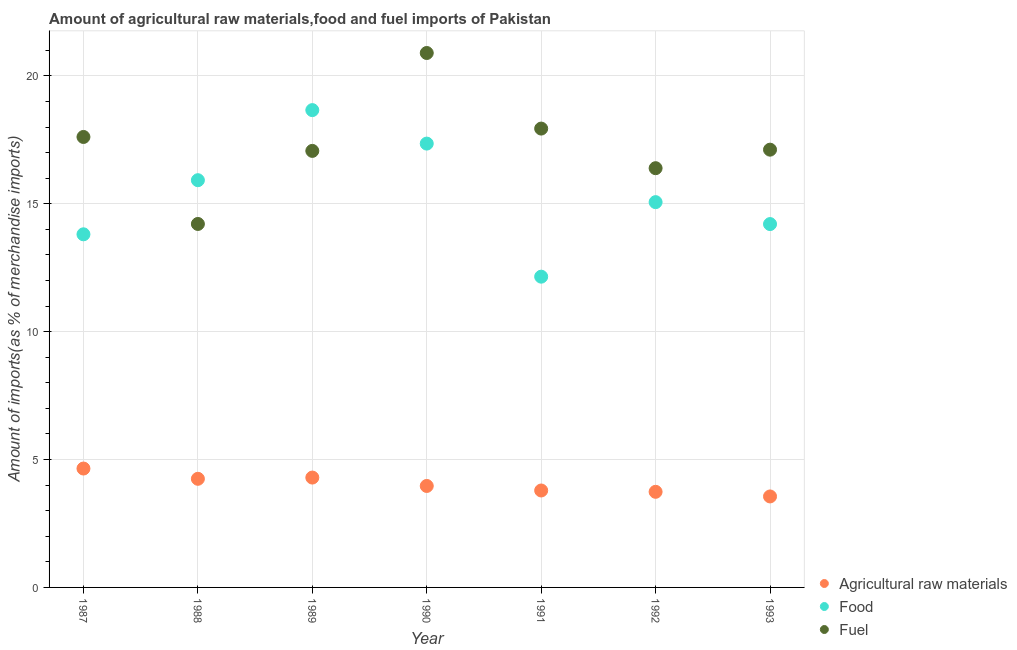Is the number of dotlines equal to the number of legend labels?
Ensure brevity in your answer.  Yes. What is the percentage of fuel imports in 1993?
Offer a terse response. 17.12. Across all years, what is the maximum percentage of food imports?
Keep it short and to the point. 18.66. Across all years, what is the minimum percentage of raw materials imports?
Provide a short and direct response. 3.56. In which year was the percentage of food imports minimum?
Offer a terse response. 1991. What is the total percentage of food imports in the graph?
Offer a terse response. 107.16. What is the difference between the percentage of food imports in 1991 and that in 1992?
Your answer should be very brief. -2.91. What is the difference between the percentage of food imports in 1988 and the percentage of raw materials imports in 1990?
Ensure brevity in your answer.  11.95. What is the average percentage of food imports per year?
Give a very brief answer. 15.31. In the year 1993, what is the difference between the percentage of food imports and percentage of fuel imports?
Provide a succinct answer. -2.91. In how many years, is the percentage of fuel imports greater than 9 %?
Give a very brief answer. 7. What is the ratio of the percentage of food imports in 1990 to that in 1993?
Give a very brief answer. 1.22. What is the difference between the highest and the second highest percentage of food imports?
Keep it short and to the point. 1.31. What is the difference between the highest and the lowest percentage of food imports?
Provide a short and direct response. 6.51. In how many years, is the percentage of fuel imports greater than the average percentage of fuel imports taken over all years?
Provide a short and direct response. 3. Is the sum of the percentage of fuel imports in 1989 and 1990 greater than the maximum percentage of raw materials imports across all years?
Your answer should be very brief. Yes. Is the percentage of food imports strictly greater than the percentage of raw materials imports over the years?
Provide a short and direct response. Yes. Is the percentage of food imports strictly less than the percentage of fuel imports over the years?
Make the answer very short. No. How many dotlines are there?
Your answer should be very brief. 3. How many years are there in the graph?
Ensure brevity in your answer.  7. What is the difference between two consecutive major ticks on the Y-axis?
Make the answer very short. 5. Does the graph contain any zero values?
Provide a short and direct response. No. Does the graph contain grids?
Provide a succinct answer. Yes. Where does the legend appear in the graph?
Make the answer very short. Bottom right. What is the title of the graph?
Offer a terse response. Amount of agricultural raw materials,food and fuel imports of Pakistan. Does "Ireland" appear as one of the legend labels in the graph?
Your answer should be compact. No. What is the label or title of the Y-axis?
Provide a short and direct response. Amount of imports(as % of merchandise imports). What is the Amount of imports(as % of merchandise imports) in Agricultural raw materials in 1987?
Your answer should be very brief. 4.65. What is the Amount of imports(as % of merchandise imports) in Food in 1987?
Provide a short and direct response. 13.81. What is the Amount of imports(as % of merchandise imports) of Fuel in 1987?
Your answer should be compact. 17.61. What is the Amount of imports(as % of merchandise imports) of Agricultural raw materials in 1988?
Provide a succinct answer. 4.25. What is the Amount of imports(as % of merchandise imports) in Food in 1988?
Make the answer very short. 15.92. What is the Amount of imports(as % of merchandise imports) in Fuel in 1988?
Keep it short and to the point. 14.21. What is the Amount of imports(as % of merchandise imports) of Agricultural raw materials in 1989?
Make the answer very short. 4.3. What is the Amount of imports(as % of merchandise imports) of Food in 1989?
Make the answer very short. 18.66. What is the Amount of imports(as % of merchandise imports) of Fuel in 1989?
Make the answer very short. 17.07. What is the Amount of imports(as % of merchandise imports) of Agricultural raw materials in 1990?
Your answer should be compact. 3.97. What is the Amount of imports(as % of merchandise imports) in Food in 1990?
Your answer should be very brief. 17.35. What is the Amount of imports(as % of merchandise imports) in Fuel in 1990?
Your answer should be very brief. 20.89. What is the Amount of imports(as % of merchandise imports) of Agricultural raw materials in 1991?
Your answer should be very brief. 3.79. What is the Amount of imports(as % of merchandise imports) in Food in 1991?
Give a very brief answer. 12.15. What is the Amount of imports(as % of merchandise imports) of Fuel in 1991?
Your answer should be compact. 17.94. What is the Amount of imports(as % of merchandise imports) of Agricultural raw materials in 1992?
Keep it short and to the point. 3.74. What is the Amount of imports(as % of merchandise imports) in Food in 1992?
Offer a terse response. 15.06. What is the Amount of imports(as % of merchandise imports) in Fuel in 1992?
Make the answer very short. 16.39. What is the Amount of imports(as % of merchandise imports) in Agricultural raw materials in 1993?
Keep it short and to the point. 3.56. What is the Amount of imports(as % of merchandise imports) of Food in 1993?
Make the answer very short. 14.21. What is the Amount of imports(as % of merchandise imports) of Fuel in 1993?
Give a very brief answer. 17.12. Across all years, what is the maximum Amount of imports(as % of merchandise imports) of Agricultural raw materials?
Offer a very short reply. 4.65. Across all years, what is the maximum Amount of imports(as % of merchandise imports) of Food?
Your answer should be compact. 18.66. Across all years, what is the maximum Amount of imports(as % of merchandise imports) in Fuel?
Provide a succinct answer. 20.89. Across all years, what is the minimum Amount of imports(as % of merchandise imports) in Agricultural raw materials?
Give a very brief answer. 3.56. Across all years, what is the minimum Amount of imports(as % of merchandise imports) in Food?
Provide a succinct answer. 12.15. Across all years, what is the minimum Amount of imports(as % of merchandise imports) of Fuel?
Offer a terse response. 14.21. What is the total Amount of imports(as % of merchandise imports) of Agricultural raw materials in the graph?
Ensure brevity in your answer.  28.24. What is the total Amount of imports(as % of merchandise imports) in Food in the graph?
Keep it short and to the point. 107.16. What is the total Amount of imports(as % of merchandise imports) of Fuel in the graph?
Offer a terse response. 121.23. What is the difference between the Amount of imports(as % of merchandise imports) of Agricultural raw materials in 1987 and that in 1988?
Ensure brevity in your answer.  0.4. What is the difference between the Amount of imports(as % of merchandise imports) of Food in 1987 and that in 1988?
Provide a short and direct response. -2.12. What is the difference between the Amount of imports(as % of merchandise imports) of Fuel in 1987 and that in 1988?
Ensure brevity in your answer.  3.4. What is the difference between the Amount of imports(as % of merchandise imports) in Agricultural raw materials in 1987 and that in 1989?
Offer a very short reply. 0.35. What is the difference between the Amount of imports(as % of merchandise imports) in Food in 1987 and that in 1989?
Make the answer very short. -4.86. What is the difference between the Amount of imports(as % of merchandise imports) in Fuel in 1987 and that in 1989?
Provide a succinct answer. 0.54. What is the difference between the Amount of imports(as % of merchandise imports) of Agricultural raw materials in 1987 and that in 1990?
Make the answer very short. 0.68. What is the difference between the Amount of imports(as % of merchandise imports) of Food in 1987 and that in 1990?
Provide a succinct answer. -3.55. What is the difference between the Amount of imports(as % of merchandise imports) in Fuel in 1987 and that in 1990?
Provide a succinct answer. -3.28. What is the difference between the Amount of imports(as % of merchandise imports) of Agricultural raw materials in 1987 and that in 1991?
Your answer should be compact. 0.86. What is the difference between the Amount of imports(as % of merchandise imports) of Food in 1987 and that in 1991?
Make the answer very short. 1.66. What is the difference between the Amount of imports(as % of merchandise imports) in Fuel in 1987 and that in 1991?
Your answer should be very brief. -0.33. What is the difference between the Amount of imports(as % of merchandise imports) of Agricultural raw materials in 1987 and that in 1992?
Offer a terse response. 0.91. What is the difference between the Amount of imports(as % of merchandise imports) of Food in 1987 and that in 1992?
Ensure brevity in your answer.  -1.26. What is the difference between the Amount of imports(as % of merchandise imports) of Fuel in 1987 and that in 1992?
Offer a terse response. 1.22. What is the difference between the Amount of imports(as % of merchandise imports) in Agricultural raw materials in 1987 and that in 1993?
Your response must be concise. 1.09. What is the difference between the Amount of imports(as % of merchandise imports) in Food in 1987 and that in 1993?
Offer a very short reply. -0.4. What is the difference between the Amount of imports(as % of merchandise imports) in Fuel in 1987 and that in 1993?
Provide a succinct answer. 0.5. What is the difference between the Amount of imports(as % of merchandise imports) in Agricultural raw materials in 1988 and that in 1989?
Your answer should be compact. -0.05. What is the difference between the Amount of imports(as % of merchandise imports) in Food in 1988 and that in 1989?
Offer a terse response. -2.74. What is the difference between the Amount of imports(as % of merchandise imports) of Fuel in 1988 and that in 1989?
Provide a succinct answer. -2.86. What is the difference between the Amount of imports(as % of merchandise imports) in Agricultural raw materials in 1988 and that in 1990?
Keep it short and to the point. 0.28. What is the difference between the Amount of imports(as % of merchandise imports) in Food in 1988 and that in 1990?
Offer a very short reply. -1.43. What is the difference between the Amount of imports(as % of merchandise imports) of Fuel in 1988 and that in 1990?
Offer a terse response. -6.68. What is the difference between the Amount of imports(as % of merchandise imports) of Agricultural raw materials in 1988 and that in 1991?
Your response must be concise. 0.46. What is the difference between the Amount of imports(as % of merchandise imports) of Food in 1988 and that in 1991?
Make the answer very short. 3.77. What is the difference between the Amount of imports(as % of merchandise imports) of Fuel in 1988 and that in 1991?
Keep it short and to the point. -3.73. What is the difference between the Amount of imports(as % of merchandise imports) in Agricultural raw materials in 1988 and that in 1992?
Provide a succinct answer. 0.51. What is the difference between the Amount of imports(as % of merchandise imports) in Food in 1988 and that in 1992?
Keep it short and to the point. 0.86. What is the difference between the Amount of imports(as % of merchandise imports) in Fuel in 1988 and that in 1992?
Give a very brief answer. -2.18. What is the difference between the Amount of imports(as % of merchandise imports) in Agricultural raw materials in 1988 and that in 1993?
Make the answer very short. 0.69. What is the difference between the Amount of imports(as % of merchandise imports) in Food in 1988 and that in 1993?
Your answer should be compact. 1.72. What is the difference between the Amount of imports(as % of merchandise imports) in Fuel in 1988 and that in 1993?
Keep it short and to the point. -2.9. What is the difference between the Amount of imports(as % of merchandise imports) of Agricultural raw materials in 1989 and that in 1990?
Keep it short and to the point. 0.33. What is the difference between the Amount of imports(as % of merchandise imports) in Food in 1989 and that in 1990?
Your response must be concise. 1.31. What is the difference between the Amount of imports(as % of merchandise imports) of Fuel in 1989 and that in 1990?
Your answer should be very brief. -3.83. What is the difference between the Amount of imports(as % of merchandise imports) of Agricultural raw materials in 1989 and that in 1991?
Offer a very short reply. 0.51. What is the difference between the Amount of imports(as % of merchandise imports) in Food in 1989 and that in 1991?
Your answer should be compact. 6.51. What is the difference between the Amount of imports(as % of merchandise imports) of Fuel in 1989 and that in 1991?
Keep it short and to the point. -0.87. What is the difference between the Amount of imports(as % of merchandise imports) in Agricultural raw materials in 1989 and that in 1992?
Ensure brevity in your answer.  0.56. What is the difference between the Amount of imports(as % of merchandise imports) of Food in 1989 and that in 1992?
Your answer should be compact. 3.6. What is the difference between the Amount of imports(as % of merchandise imports) of Fuel in 1989 and that in 1992?
Your answer should be compact. 0.68. What is the difference between the Amount of imports(as % of merchandise imports) in Agricultural raw materials in 1989 and that in 1993?
Keep it short and to the point. 0.74. What is the difference between the Amount of imports(as % of merchandise imports) of Food in 1989 and that in 1993?
Keep it short and to the point. 4.46. What is the difference between the Amount of imports(as % of merchandise imports) in Fuel in 1989 and that in 1993?
Ensure brevity in your answer.  -0.05. What is the difference between the Amount of imports(as % of merchandise imports) of Agricultural raw materials in 1990 and that in 1991?
Provide a short and direct response. 0.18. What is the difference between the Amount of imports(as % of merchandise imports) in Food in 1990 and that in 1991?
Provide a short and direct response. 5.2. What is the difference between the Amount of imports(as % of merchandise imports) in Fuel in 1990 and that in 1991?
Your answer should be very brief. 2.96. What is the difference between the Amount of imports(as % of merchandise imports) of Agricultural raw materials in 1990 and that in 1992?
Your answer should be very brief. 0.23. What is the difference between the Amount of imports(as % of merchandise imports) of Food in 1990 and that in 1992?
Keep it short and to the point. 2.29. What is the difference between the Amount of imports(as % of merchandise imports) of Fuel in 1990 and that in 1992?
Offer a very short reply. 4.5. What is the difference between the Amount of imports(as % of merchandise imports) of Agricultural raw materials in 1990 and that in 1993?
Your answer should be compact. 0.41. What is the difference between the Amount of imports(as % of merchandise imports) in Food in 1990 and that in 1993?
Provide a succinct answer. 3.15. What is the difference between the Amount of imports(as % of merchandise imports) in Fuel in 1990 and that in 1993?
Give a very brief answer. 3.78. What is the difference between the Amount of imports(as % of merchandise imports) of Agricultural raw materials in 1991 and that in 1992?
Keep it short and to the point. 0.05. What is the difference between the Amount of imports(as % of merchandise imports) in Food in 1991 and that in 1992?
Your response must be concise. -2.91. What is the difference between the Amount of imports(as % of merchandise imports) of Fuel in 1991 and that in 1992?
Offer a terse response. 1.55. What is the difference between the Amount of imports(as % of merchandise imports) in Agricultural raw materials in 1991 and that in 1993?
Give a very brief answer. 0.23. What is the difference between the Amount of imports(as % of merchandise imports) in Food in 1991 and that in 1993?
Give a very brief answer. -2.06. What is the difference between the Amount of imports(as % of merchandise imports) in Fuel in 1991 and that in 1993?
Make the answer very short. 0.82. What is the difference between the Amount of imports(as % of merchandise imports) of Agricultural raw materials in 1992 and that in 1993?
Your response must be concise. 0.18. What is the difference between the Amount of imports(as % of merchandise imports) in Food in 1992 and that in 1993?
Keep it short and to the point. 0.86. What is the difference between the Amount of imports(as % of merchandise imports) in Fuel in 1992 and that in 1993?
Your answer should be very brief. -0.72. What is the difference between the Amount of imports(as % of merchandise imports) in Agricultural raw materials in 1987 and the Amount of imports(as % of merchandise imports) in Food in 1988?
Provide a short and direct response. -11.27. What is the difference between the Amount of imports(as % of merchandise imports) in Agricultural raw materials in 1987 and the Amount of imports(as % of merchandise imports) in Fuel in 1988?
Offer a very short reply. -9.56. What is the difference between the Amount of imports(as % of merchandise imports) in Food in 1987 and the Amount of imports(as % of merchandise imports) in Fuel in 1988?
Provide a short and direct response. -0.4. What is the difference between the Amount of imports(as % of merchandise imports) of Agricultural raw materials in 1987 and the Amount of imports(as % of merchandise imports) of Food in 1989?
Provide a short and direct response. -14.01. What is the difference between the Amount of imports(as % of merchandise imports) in Agricultural raw materials in 1987 and the Amount of imports(as % of merchandise imports) in Fuel in 1989?
Offer a terse response. -12.42. What is the difference between the Amount of imports(as % of merchandise imports) of Food in 1987 and the Amount of imports(as % of merchandise imports) of Fuel in 1989?
Offer a terse response. -3.26. What is the difference between the Amount of imports(as % of merchandise imports) of Agricultural raw materials in 1987 and the Amount of imports(as % of merchandise imports) of Food in 1990?
Your answer should be compact. -12.7. What is the difference between the Amount of imports(as % of merchandise imports) of Agricultural raw materials in 1987 and the Amount of imports(as % of merchandise imports) of Fuel in 1990?
Make the answer very short. -16.25. What is the difference between the Amount of imports(as % of merchandise imports) in Food in 1987 and the Amount of imports(as % of merchandise imports) in Fuel in 1990?
Offer a very short reply. -7.09. What is the difference between the Amount of imports(as % of merchandise imports) of Agricultural raw materials in 1987 and the Amount of imports(as % of merchandise imports) of Food in 1991?
Provide a short and direct response. -7.5. What is the difference between the Amount of imports(as % of merchandise imports) in Agricultural raw materials in 1987 and the Amount of imports(as % of merchandise imports) in Fuel in 1991?
Offer a very short reply. -13.29. What is the difference between the Amount of imports(as % of merchandise imports) in Food in 1987 and the Amount of imports(as % of merchandise imports) in Fuel in 1991?
Ensure brevity in your answer.  -4.13. What is the difference between the Amount of imports(as % of merchandise imports) of Agricultural raw materials in 1987 and the Amount of imports(as % of merchandise imports) of Food in 1992?
Make the answer very short. -10.42. What is the difference between the Amount of imports(as % of merchandise imports) in Agricultural raw materials in 1987 and the Amount of imports(as % of merchandise imports) in Fuel in 1992?
Your response must be concise. -11.74. What is the difference between the Amount of imports(as % of merchandise imports) of Food in 1987 and the Amount of imports(as % of merchandise imports) of Fuel in 1992?
Your answer should be compact. -2.58. What is the difference between the Amount of imports(as % of merchandise imports) of Agricultural raw materials in 1987 and the Amount of imports(as % of merchandise imports) of Food in 1993?
Your response must be concise. -9.56. What is the difference between the Amount of imports(as % of merchandise imports) of Agricultural raw materials in 1987 and the Amount of imports(as % of merchandise imports) of Fuel in 1993?
Provide a short and direct response. -12.47. What is the difference between the Amount of imports(as % of merchandise imports) in Food in 1987 and the Amount of imports(as % of merchandise imports) in Fuel in 1993?
Your response must be concise. -3.31. What is the difference between the Amount of imports(as % of merchandise imports) of Agricultural raw materials in 1988 and the Amount of imports(as % of merchandise imports) of Food in 1989?
Ensure brevity in your answer.  -14.41. What is the difference between the Amount of imports(as % of merchandise imports) in Agricultural raw materials in 1988 and the Amount of imports(as % of merchandise imports) in Fuel in 1989?
Your response must be concise. -12.82. What is the difference between the Amount of imports(as % of merchandise imports) of Food in 1988 and the Amount of imports(as % of merchandise imports) of Fuel in 1989?
Your response must be concise. -1.15. What is the difference between the Amount of imports(as % of merchandise imports) in Agricultural raw materials in 1988 and the Amount of imports(as % of merchandise imports) in Food in 1990?
Provide a short and direct response. -13.11. What is the difference between the Amount of imports(as % of merchandise imports) in Agricultural raw materials in 1988 and the Amount of imports(as % of merchandise imports) in Fuel in 1990?
Provide a short and direct response. -16.65. What is the difference between the Amount of imports(as % of merchandise imports) of Food in 1988 and the Amount of imports(as % of merchandise imports) of Fuel in 1990?
Your response must be concise. -4.97. What is the difference between the Amount of imports(as % of merchandise imports) in Agricultural raw materials in 1988 and the Amount of imports(as % of merchandise imports) in Food in 1991?
Offer a very short reply. -7.9. What is the difference between the Amount of imports(as % of merchandise imports) in Agricultural raw materials in 1988 and the Amount of imports(as % of merchandise imports) in Fuel in 1991?
Ensure brevity in your answer.  -13.69. What is the difference between the Amount of imports(as % of merchandise imports) in Food in 1988 and the Amount of imports(as % of merchandise imports) in Fuel in 1991?
Give a very brief answer. -2.02. What is the difference between the Amount of imports(as % of merchandise imports) in Agricultural raw materials in 1988 and the Amount of imports(as % of merchandise imports) in Food in 1992?
Keep it short and to the point. -10.82. What is the difference between the Amount of imports(as % of merchandise imports) of Agricultural raw materials in 1988 and the Amount of imports(as % of merchandise imports) of Fuel in 1992?
Offer a very short reply. -12.14. What is the difference between the Amount of imports(as % of merchandise imports) in Food in 1988 and the Amount of imports(as % of merchandise imports) in Fuel in 1992?
Give a very brief answer. -0.47. What is the difference between the Amount of imports(as % of merchandise imports) of Agricultural raw materials in 1988 and the Amount of imports(as % of merchandise imports) of Food in 1993?
Provide a succinct answer. -9.96. What is the difference between the Amount of imports(as % of merchandise imports) in Agricultural raw materials in 1988 and the Amount of imports(as % of merchandise imports) in Fuel in 1993?
Offer a very short reply. -12.87. What is the difference between the Amount of imports(as % of merchandise imports) in Food in 1988 and the Amount of imports(as % of merchandise imports) in Fuel in 1993?
Provide a succinct answer. -1.19. What is the difference between the Amount of imports(as % of merchandise imports) in Agricultural raw materials in 1989 and the Amount of imports(as % of merchandise imports) in Food in 1990?
Make the answer very short. -13.06. What is the difference between the Amount of imports(as % of merchandise imports) in Agricultural raw materials in 1989 and the Amount of imports(as % of merchandise imports) in Fuel in 1990?
Your answer should be compact. -16.6. What is the difference between the Amount of imports(as % of merchandise imports) in Food in 1989 and the Amount of imports(as % of merchandise imports) in Fuel in 1990?
Keep it short and to the point. -2.23. What is the difference between the Amount of imports(as % of merchandise imports) in Agricultural raw materials in 1989 and the Amount of imports(as % of merchandise imports) in Food in 1991?
Provide a short and direct response. -7.85. What is the difference between the Amount of imports(as % of merchandise imports) in Agricultural raw materials in 1989 and the Amount of imports(as % of merchandise imports) in Fuel in 1991?
Your answer should be very brief. -13.64. What is the difference between the Amount of imports(as % of merchandise imports) in Food in 1989 and the Amount of imports(as % of merchandise imports) in Fuel in 1991?
Your answer should be very brief. 0.72. What is the difference between the Amount of imports(as % of merchandise imports) of Agricultural raw materials in 1989 and the Amount of imports(as % of merchandise imports) of Food in 1992?
Your response must be concise. -10.77. What is the difference between the Amount of imports(as % of merchandise imports) in Agricultural raw materials in 1989 and the Amount of imports(as % of merchandise imports) in Fuel in 1992?
Your answer should be very brief. -12.1. What is the difference between the Amount of imports(as % of merchandise imports) of Food in 1989 and the Amount of imports(as % of merchandise imports) of Fuel in 1992?
Provide a short and direct response. 2.27. What is the difference between the Amount of imports(as % of merchandise imports) of Agricultural raw materials in 1989 and the Amount of imports(as % of merchandise imports) of Food in 1993?
Your answer should be very brief. -9.91. What is the difference between the Amount of imports(as % of merchandise imports) of Agricultural raw materials in 1989 and the Amount of imports(as % of merchandise imports) of Fuel in 1993?
Offer a very short reply. -12.82. What is the difference between the Amount of imports(as % of merchandise imports) in Food in 1989 and the Amount of imports(as % of merchandise imports) in Fuel in 1993?
Make the answer very short. 1.55. What is the difference between the Amount of imports(as % of merchandise imports) in Agricultural raw materials in 1990 and the Amount of imports(as % of merchandise imports) in Food in 1991?
Your response must be concise. -8.18. What is the difference between the Amount of imports(as % of merchandise imports) of Agricultural raw materials in 1990 and the Amount of imports(as % of merchandise imports) of Fuel in 1991?
Keep it short and to the point. -13.97. What is the difference between the Amount of imports(as % of merchandise imports) in Food in 1990 and the Amount of imports(as % of merchandise imports) in Fuel in 1991?
Provide a short and direct response. -0.59. What is the difference between the Amount of imports(as % of merchandise imports) of Agricultural raw materials in 1990 and the Amount of imports(as % of merchandise imports) of Food in 1992?
Provide a short and direct response. -11.1. What is the difference between the Amount of imports(as % of merchandise imports) of Agricultural raw materials in 1990 and the Amount of imports(as % of merchandise imports) of Fuel in 1992?
Ensure brevity in your answer.  -12.42. What is the difference between the Amount of imports(as % of merchandise imports) of Food in 1990 and the Amount of imports(as % of merchandise imports) of Fuel in 1992?
Provide a succinct answer. 0.96. What is the difference between the Amount of imports(as % of merchandise imports) of Agricultural raw materials in 1990 and the Amount of imports(as % of merchandise imports) of Food in 1993?
Keep it short and to the point. -10.24. What is the difference between the Amount of imports(as % of merchandise imports) of Agricultural raw materials in 1990 and the Amount of imports(as % of merchandise imports) of Fuel in 1993?
Ensure brevity in your answer.  -13.15. What is the difference between the Amount of imports(as % of merchandise imports) in Food in 1990 and the Amount of imports(as % of merchandise imports) in Fuel in 1993?
Provide a short and direct response. 0.24. What is the difference between the Amount of imports(as % of merchandise imports) of Agricultural raw materials in 1991 and the Amount of imports(as % of merchandise imports) of Food in 1992?
Your answer should be compact. -11.27. What is the difference between the Amount of imports(as % of merchandise imports) of Agricultural raw materials in 1991 and the Amount of imports(as % of merchandise imports) of Fuel in 1992?
Provide a succinct answer. -12.6. What is the difference between the Amount of imports(as % of merchandise imports) of Food in 1991 and the Amount of imports(as % of merchandise imports) of Fuel in 1992?
Keep it short and to the point. -4.24. What is the difference between the Amount of imports(as % of merchandise imports) in Agricultural raw materials in 1991 and the Amount of imports(as % of merchandise imports) in Food in 1993?
Your response must be concise. -10.42. What is the difference between the Amount of imports(as % of merchandise imports) in Agricultural raw materials in 1991 and the Amount of imports(as % of merchandise imports) in Fuel in 1993?
Provide a succinct answer. -13.33. What is the difference between the Amount of imports(as % of merchandise imports) in Food in 1991 and the Amount of imports(as % of merchandise imports) in Fuel in 1993?
Your response must be concise. -4.97. What is the difference between the Amount of imports(as % of merchandise imports) of Agricultural raw materials in 1992 and the Amount of imports(as % of merchandise imports) of Food in 1993?
Provide a succinct answer. -10.47. What is the difference between the Amount of imports(as % of merchandise imports) of Agricultural raw materials in 1992 and the Amount of imports(as % of merchandise imports) of Fuel in 1993?
Your answer should be compact. -13.38. What is the difference between the Amount of imports(as % of merchandise imports) in Food in 1992 and the Amount of imports(as % of merchandise imports) in Fuel in 1993?
Ensure brevity in your answer.  -2.05. What is the average Amount of imports(as % of merchandise imports) in Agricultural raw materials per year?
Make the answer very short. 4.03. What is the average Amount of imports(as % of merchandise imports) in Food per year?
Your answer should be very brief. 15.31. What is the average Amount of imports(as % of merchandise imports) of Fuel per year?
Your response must be concise. 17.32. In the year 1987, what is the difference between the Amount of imports(as % of merchandise imports) of Agricultural raw materials and Amount of imports(as % of merchandise imports) of Food?
Offer a terse response. -9.16. In the year 1987, what is the difference between the Amount of imports(as % of merchandise imports) of Agricultural raw materials and Amount of imports(as % of merchandise imports) of Fuel?
Your answer should be very brief. -12.96. In the year 1987, what is the difference between the Amount of imports(as % of merchandise imports) in Food and Amount of imports(as % of merchandise imports) in Fuel?
Offer a terse response. -3.81. In the year 1988, what is the difference between the Amount of imports(as % of merchandise imports) of Agricultural raw materials and Amount of imports(as % of merchandise imports) of Food?
Your answer should be compact. -11.67. In the year 1988, what is the difference between the Amount of imports(as % of merchandise imports) of Agricultural raw materials and Amount of imports(as % of merchandise imports) of Fuel?
Make the answer very short. -9.96. In the year 1988, what is the difference between the Amount of imports(as % of merchandise imports) of Food and Amount of imports(as % of merchandise imports) of Fuel?
Your response must be concise. 1.71. In the year 1989, what is the difference between the Amount of imports(as % of merchandise imports) in Agricultural raw materials and Amount of imports(as % of merchandise imports) in Food?
Make the answer very short. -14.37. In the year 1989, what is the difference between the Amount of imports(as % of merchandise imports) of Agricultural raw materials and Amount of imports(as % of merchandise imports) of Fuel?
Ensure brevity in your answer.  -12.77. In the year 1989, what is the difference between the Amount of imports(as % of merchandise imports) of Food and Amount of imports(as % of merchandise imports) of Fuel?
Offer a very short reply. 1.59. In the year 1990, what is the difference between the Amount of imports(as % of merchandise imports) of Agricultural raw materials and Amount of imports(as % of merchandise imports) of Food?
Offer a terse response. -13.39. In the year 1990, what is the difference between the Amount of imports(as % of merchandise imports) of Agricultural raw materials and Amount of imports(as % of merchandise imports) of Fuel?
Keep it short and to the point. -16.93. In the year 1990, what is the difference between the Amount of imports(as % of merchandise imports) in Food and Amount of imports(as % of merchandise imports) in Fuel?
Ensure brevity in your answer.  -3.54. In the year 1991, what is the difference between the Amount of imports(as % of merchandise imports) of Agricultural raw materials and Amount of imports(as % of merchandise imports) of Food?
Offer a terse response. -8.36. In the year 1991, what is the difference between the Amount of imports(as % of merchandise imports) in Agricultural raw materials and Amount of imports(as % of merchandise imports) in Fuel?
Give a very brief answer. -14.15. In the year 1991, what is the difference between the Amount of imports(as % of merchandise imports) of Food and Amount of imports(as % of merchandise imports) of Fuel?
Ensure brevity in your answer.  -5.79. In the year 1992, what is the difference between the Amount of imports(as % of merchandise imports) in Agricultural raw materials and Amount of imports(as % of merchandise imports) in Food?
Your response must be concise. -11.33. In the year 1992, what is the difference between the Amount of imports(as % of merchandise imports) of Agricultural raw materials and Amount of imports(as % of merchandise imports) of Fuel?
Provide a succinct answer. -12.65. In the year 1992, what is the difference between the Amount of imports(as % of merchandise imports) of Food and Amount of imports(as % of merchandise imports) of Fuel?
Offer a very short reply. -1.33. In the year 1993, what is the difference between the Amount of imports(as % of merchandise imports) of Agricultural raw materials and Amount of imports(as % of merchandise imports) of Food?
Your answer should be very brief. -10.65. In the year 1993, what is the difference between the Amount of imports(as % of merchandise imports) in Agricultural raw materials and Amount of imports(as % of merchandise imports) in Fuel?
Your answer should be very brief. -13.56. In the year 1993, what is the difference between the Amount of imports(as % of merchandise imports) of Food and Amount of imports(as % of merchandise imports) of Fuel?
Provide a succinct answer. -2.91. What is the ratio of the Amount of imports(as % of merchandise imports) of Agricultural raw materials in 1987 to that in 1988?
Provide a short and direct response. 1.09. What is the ratio of the Amount of imports(as % of merchandise imports) of Food in 1987 to that in 1988?
Your answer should be compact. 0.87. What is the ratio of the Amount of imports(as % of merchandise imports) of Fuel in 1987 to that in 1988?
Ensure brevity in your answer.  1.24. What is the ratio of the Amount of imports(as % of merchandise imports) of Agricultural raw materials in 1987 to that in 1989?
Offer a very short reply. 1.08. What is the ratio of the Amount of imports(as % of merchandise imports) in Food in 1987 to that in 1989?
Make the answer very short. 0.74. What is the ratio of the Amount of imports(as % of merchandise imports) in Fuel in 1987 to that in 1989?
Keep it short and to the point. 1.03. What is the ratio of the Amount of imports(as % of merchandise imports) of Agricultural raw materials in 1987 to that in 1990?
Keep it short and to the point. 1.17. What is the ratio of the Amount of imports(as % of merchandise imports) in Food in 1987 to that in 1990?
Your answer should be compact. 0.8. What is the ratio of the Amount of imports(as % of merchandise imports) of Fuel in 1987 to that in 1990?
Offer a terse response. 0.84. What is the ratio of the Amount of imports(as % of merchandise imports) in Agricultural raw materials in 1987 to that in 1991?
Your answer should be compact. 1.23. What is the ratio of the Amount of imports(as % of merchandise imports) in Food in 1987 to that in 1991?
Offer a terse response. 1.14. What is the ratio of the Amount of imports(as % of merchandise imports) in Fuel in 1987 to that in 1991?
Ensure brevity in your answer.  0.98. What is the ratio of the Amount of imports(as % of merchandise imports) of Agricultural raw materials in 1987 to that in 1992?
Make the answer very short. 1.24. What is the ratio of the Amount of imports(as % of merchandise imports) of Food in 1987 to that in 1992?
Your answer should be very brief. 0.92. What is the ratio of the Amount of imports(as % of merchandise imports) of Fuel in 1987 to that in 1992?
Offer a very short reply. 1.07. What is the ratio of the Amount of imports(as % of merchandise imports) of Agricultural raw materials in 1987 to that in 1993?
Provide a succinct answer. 1.31. What is the ratio of the Amount of imports(as % of merchandise imports) of Food in 1987 to that in 1993?
Provide a short and direct response. 0.97. What is the ratio of the Amount of imports(as % of merchandise imports) in Fuel in 1987 to that in 1993?
Provide a succinct answer. 1.03. What is the ratio of the Amount of imports(as % of merchandise imports) in Agricultural raw materials in 1988 to that in 1989?
Your answer should be compact. 0.99. What is the ratio of the Amount of imports(as % of merchandise imports) in Food in 1988 to that in 1989?
Offer a terse response. 0.85. What is the ratio of the Amount of imports(as % of merchandise imports) of Fuel in 1988 to that in 1989?
Offer a very short reply. 0.83. What is the ratio of the Amount of imports(as % of merchandise imports) of Agricultural raw materials in 1988 to that in 1990?
Ensure brevity in your answer.  1.07. What is the ratio of the Amount of imports(as % of merchandise imports) of Food in 1988 to that in 1990?
Provide a succinct answer. 0.92. What is the ratio of the Amount of imports(as % of merchandise imports) of Fuel in 1988 to that in 1990?
Ensure brevity in your answer.  0.68. What is the ratio of the Amount of imports(as % of merchandise imports) of Agricultural raw materials in 1988 to that in 1991?
Your answer should be compact. 1.12. What is the ratio of the Amount of imports(as % of merchandise imports) in Food in 1988 to that in 1991?
Offer a terse response. 1.31. What is the ratio of the Amount of imports(as % of merchandise imports) in Fuel in 1988 to that in 1991?
Offer a terse response. 0.79. What is the ratio of the Amount of imports(as % of merchandise imports) of Agricultural raw materials in 1988 to that in 1992?
Your answer should be compact. 1.14. What is the ratio of the Amount of imports(as % of merchandise imports) of Food in 1988 to that in 1992?
Provide a short and direct response. 1.06. What is the ratio of the Amount of imports(as % of merchandise imports) in Fuel in 1988 to that in 1992?
Your answer should be very brief. 0.87. What is the ratio of the Amount of imports(as % of merchandise imports) in Agricultural raw materials in 1988 to that in 1993?
Offer a very short reply. 1.19. What is the ratio of the Amount of imports(as % of merchandise imports) of Food in 1988 to that in 1993?
Keep it short and to the point. 1.12. What is the ratio of the Amount of imports(as % of merchandise imports) in Fuel in 1988 to that in 1993?
Your answer should be very brief. 0.83. What is the ratio of the Amount of imports(as % of merchandise imports) of Agricultural raw materials in 1989 to that in 1990?
Provide a succinct answer. 1.08. What is the ratio of the Amount of imports(as % of merchandise imports) in Food in 1989 to that in 1990?
Provide a succinct answer. 1.08. What is the ratio of the Amount of imports(as % of merchandise imports) of Fuel in 1989 to that in 1990?
Ensure brevity in your answer.  0.82. What is the ratio of the Amount of imports(as % of merchandise imports) in Agricultural raw materials in 1989 to that in 1991?
Offer a terse response. 1.13. What is the ratio of the Amount of imports(as % of merchandise imports) in Food in 1989 to that in 1991?
Your answer should be very brief. 1.54. What is the ratio of the Amount of imports(as % of merchandise imports) of Fuel in 1989 to that in 1991?
Offer a very short reply. 0.95. What is the ratio of the Amount of imports(as % of merchandise imports) in Agricultural raw materials in 1989 to that in 1992?
Offer a terse response. 1.15. What is the ratio of the Amount of imports(as % of merchandise imports) in Food in 1989 to that in 1992?
Your response must be concise. 1.24. What is the ratio of the Amount of imports(as % of merchandise imports) of Fuel in 1989 to that in 1992?
Your answer should be compact. 1.04. What is the ratio of the Amount of imports(as % of merchandise imports) of Agricultural raw materials in 1989 to that in 1993?
Make the answer very short. 1.21. What is the ratio of the Amount of imports(as % of merchandise imports) of Food in 1989 to that in 1993?
Your response must be concise. 1.31. What is the ratio of the Amount of imports(as % of merchandise imports) of Fuel in 1989 to that in 1993?
Your answer should be very brief. 1. What is the ratio of the Amount of imports(as % of merchandise imports) in Agricultural raw materials in 1990 to that in 1991?
Your answer should be very brief. 1.05. What is the ratio of the Amount of imports(as % of merchandise imports) of Food in 1990 to that in 1991?
Offer a very short reply. 1.43. What is the ratio of the Amount of imports(as % of merchandise imports) in Fuel in 1990 to that in 1991?
Provide a short and direct response. 1.16. What is the ratio of the Amount of imports(as % of merchandise imports) of Agricultural raw materials in 1990 to that in 1992?
Your answer should be compact. 1.06. What is the ratio of the Amount of imports(as % of merchandise imports) of Food in 1990 to that in 1992?
Ensure brevity in your answer.  1.15. What is the ratio of the Amount of imports(as % of merchandise imports) of Fuel in 1990 to that in 1992?
Give a very brief answer. 1.27. What is the ratio of the Amount of imports(as % of merchandise imports) of Agricultural raw materials in 1990 to that in 1993?
Make the answer very short. 1.12. What is the ratio of the Amount of imports(as % of merchandise imports) in Food in 1990 to that in 1993?
Keep it short and to the point. 1.22. What is the ratio of the Amount of imports(as % of merchandise imports) in Fuel in 1990 to that in 1993?
Your answer should be very brief. 1.22. What is the ratio of the Amount of imports(as % of merchandise imports) in Agricultural raw materials in 1991 to that in 1992?
Your response must be concise. 1.01. What is the ratio of the Amount of imports(as % of merchandise imports) of Food in 1991 to that in 1992?
Provide a short and direct response. 0.81. What is the ratio of the Amount of imports(as % of merchandise imports) in Fuel in 1991 to that in 1992?
Make the answer very short. 1.09. What is the ratio of the Amount of imports(as % of merchandise imports) of Agricultural raw materials in 1991 to that in 1993?
Ensure brevity in your answer.  1.07. What is the ratio of the Amount of imports(as % of merchandise imports) of Food in 1991 to that in 1993?
Keep it short and to the point. 0.86. What is the ratio of the Amount of imports(as % of merchandise imports) of Fuel in 1991 to that in 1993?
Ensure brevity in your answer.  1.05. What is the ratio of the Amount of imports(as % of merchandise imports) in Agricultural raw materials in 1992 to that in 1993?
Keep it short and to the point. 1.05. What is the ratio of the Amount of imports(as % of merchandise imports) in Food in 1992 to that in 1993?
Your answer should be very brief. 1.06. What is the ratio of the Amount of imports(as % of merchandise imports) in Fuel in 1992 to that in 1993?
Ensure brevity in your answer.  0.96. What is the difference between the highest and the second highest Amount of imports(as % of merchandise imports) in Agricultural raw materials?
Ensure brevity in your answer.  0.35. What is the difference between the highest and the second highest Amount of imports(as % of merchandise imports) of Food?
Make the answer very short. 1.31. What is the difference between the highest and the second highest Amount of imports(as % of merchandise imports) of Fuel?
Your answer should be compact. 2.96. What is the difference between the highest and the lowest Amount of imports(as % of merchandise imports) of Agricultural raw materials?
Make the answer very short. 1.09. What is the difference between the highest and the lowest Amount of imports(as % of merchandise imports) in Food?
Provide a short and direct response. 6.51. What is the difference between the highest and the lowest Amount of imports(as % of merchandise imports) of Fuel?
Your answer should be compact. 6.68. 